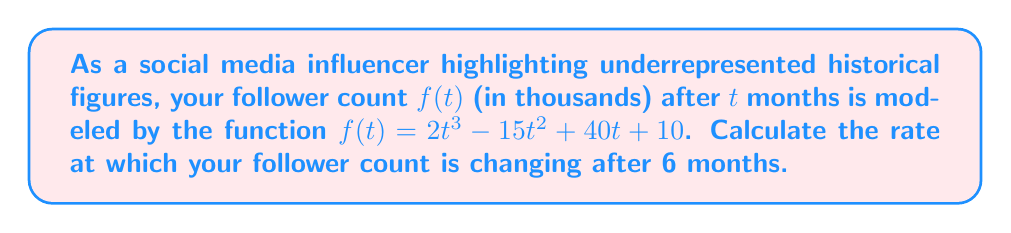Provide a solution to this math problem. To find the rate of change in followers after 6 months, we need to:

1. Find the derivative of the follower function $f(t)$.
2. Evaluate the derivative at $t = 6$.

Step 1: Find the derivative of $f(t)$
$$f(t) = 2t^3 - 15t^2 + 40t + 10$$
Using the power rule and constant rule:
$$f'(t) = 6t^2 - 30t + 40$$

Step 2: Evaluate $f'(t)$ at $t = 6$
$$f'(6) = 6(6)^2 - 30(6) + 40$$
$$= 6(36) - 180 + 40$$
$$= 216 - 180 + 40$$
$$= 76$$

The rate of change is measured in thousands of followers per month. Therefore, the final answer is 76,000 followers per month.
Answer: 76,000 followers/month 